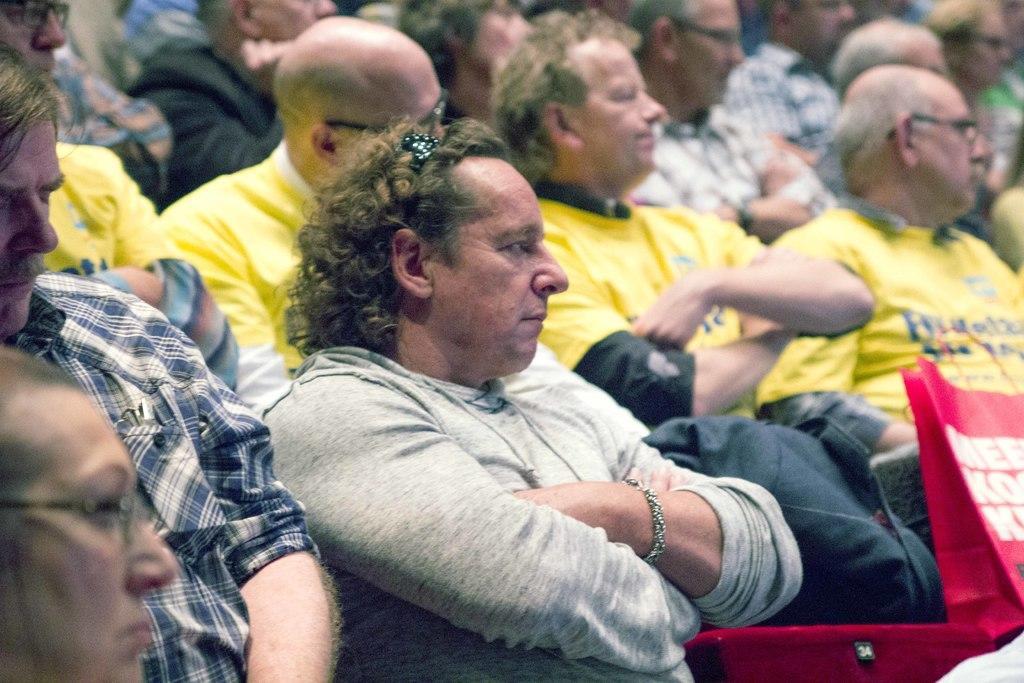Can you describe this image briefly? In this image we can see group[ of people. Four people are wearing yellow t shirt. One person wearing spectacles. In the foreground ,we can see a red bag with some text on it. 